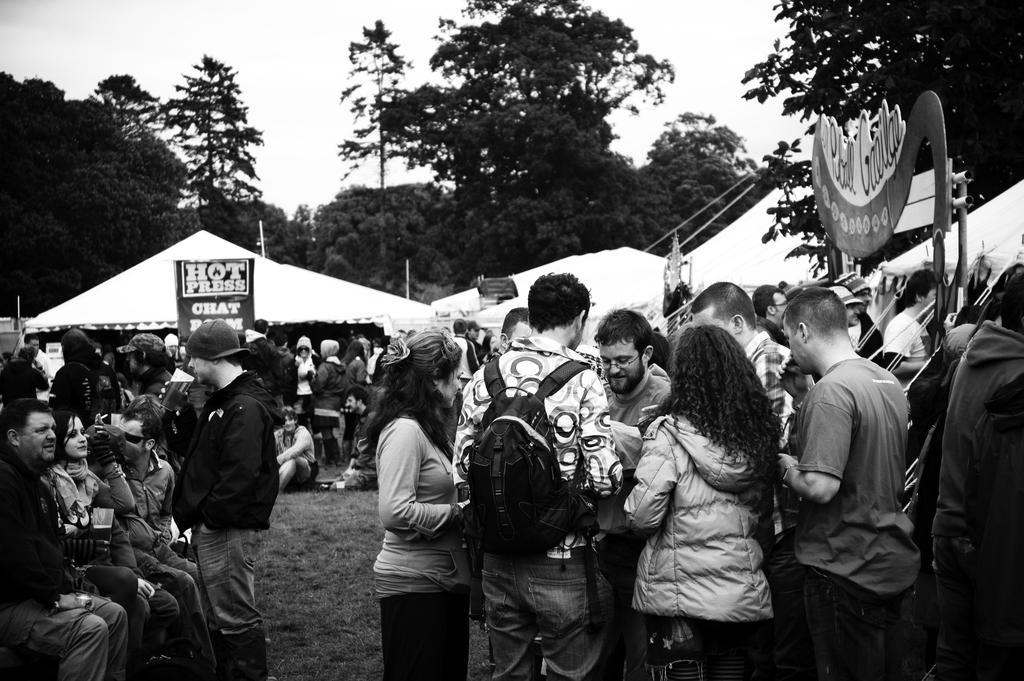Describe this image in one or two sentences. In the center of the image we can see people sitting and some of them are standing. In the background there are tents and boards. We can see trees. At the top there is sky. 